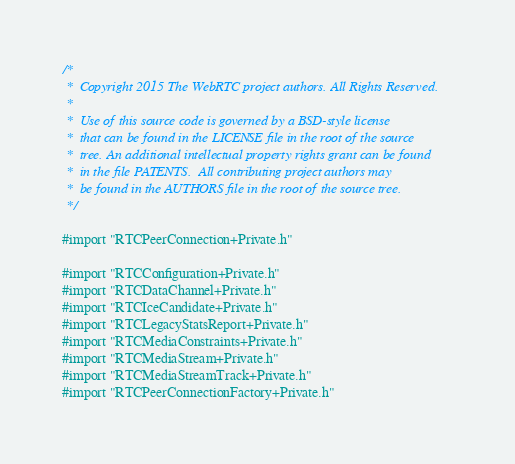Convert code to text. <code><loc_0><loc_0><loc_500><loc_500><_ObjectiveC_>/*
 *  Copyright 2015 The WebRTC project authors. All Rights Reserved.
 *
 *  Use of this source code is governed by a BSD-style license
 *  that can be found in the LICENSE file in the root of the source
 *  tree. An additional intellectual property rights grant can be found
 *  in the file PATENTS.  All contributing project authors may
 *  be found in the AUTHORS file in the root of the source tree.
 */

#import "RTCPeerConnection+Private.h"

#import "RTCConfiguration+Private.h"
#import "RTCDataChannel+Private.h"
#import "RTCIceCandidate+Private.h"
#import "RTCLegacyStatsReport+Private.h"
#import "RTCMediaConstraints+Private.h"
#import "RTCMediaStream+Private.h"
#import "RTCMediaStreamTrack+Private.h"
#import "RTCPeerConnectionFactory+Private.h"</code> 